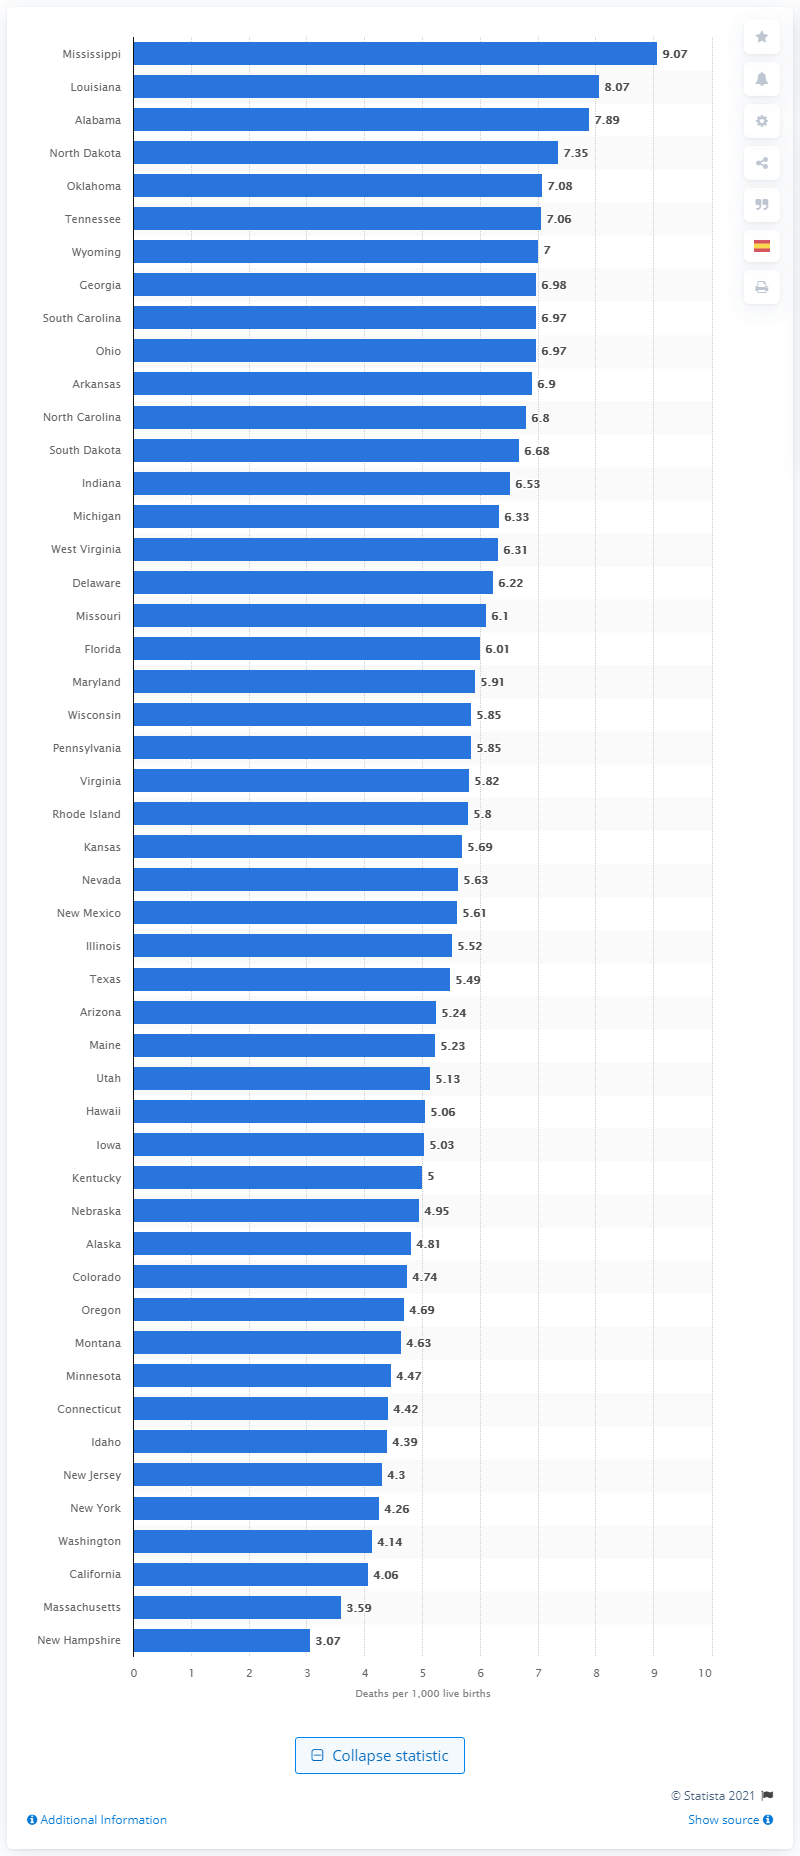Indicate a few pertinent items in this graphic. Mississippi had the highest infant mortality rate in the United States in 2019, according to data. 